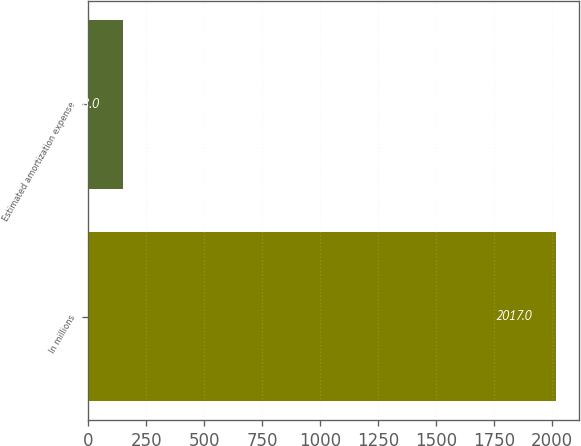<chart> <loc_0><loc_0><loc_500><loc_500><bar_chart><fcel>In millions<fcel>Estimated amortization expense<nl><fcel>2017<fcel>148<nl></chart> 